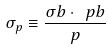<formula> <loc_0><loc_0><loc_500><loc_500>\sigma _ { p } \equiv \frac { \sigma b \cdot \ p b } { p }</formula> 